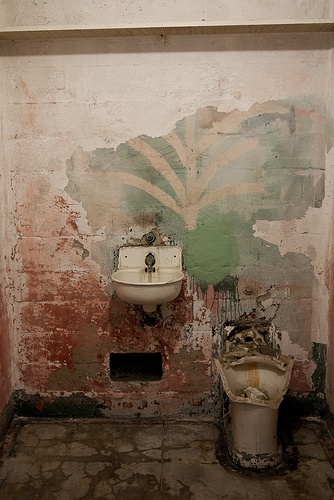Describe the objects in this image and their specific colors. I can see toilet in tan, maroon, black, and gray tones and sink in tan, gray, and maroon tones in this image. 